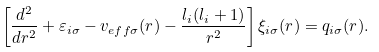<formula> <loc_0><loc_0><loc_500><loc_500>\left [ \frac { d ^ { 2 } } { d r ^ { 2 } } + \varepsilon _ { i \sigma } - v _ { e f f \sigma } ( r ) - \frac { l _ { i } ( l _ { i } + 1 ) } { r ^ { 2 } } \right ] \xi _ { i \sigma } ( r ) = q _ { i \sigma } ( r ) .</formula> 